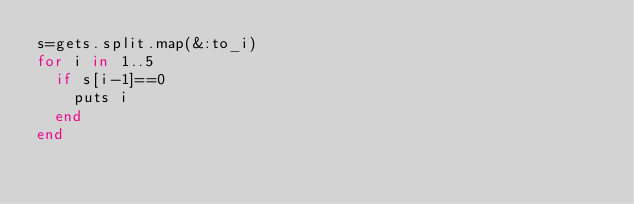<code> <loc_0><loc_0><loc_500><loc_500><_Ruby_>s=gets.split.map(&:to_i)
for i in 1..5
  if s[i-1]==0
    puts i
  end
end
</code> 